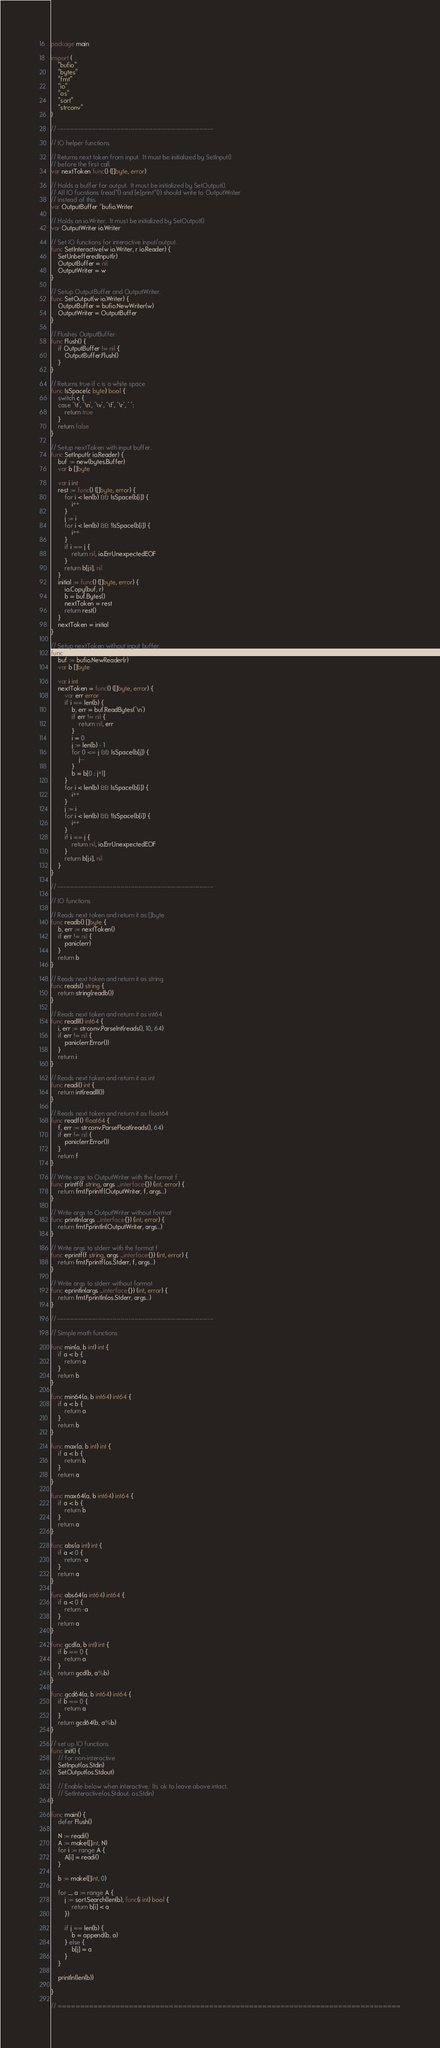<code> <loc_0><loc_0><loc_500><loc_500><_Go_>package main

import (
	"bufio"
	"bytes"
	"fmt"
	"io"
	"os"
	"sort"
	"strconv"
)

// -----------------------------------------------------------------------------

// IO helper functions

// Returns next token from input.  It must be initialized by SetInput()
// before the first call.
var nextToken func() ([]byte, error)

// Holds a buffer for output.  It must be initialized by SetOutput().
// All IO fucntions (read*() and [e]print*()) should write to OutputWriter
// instead of this.
var OutputBuffer *bufio.Writer

// Holds an io.Writer.  It must be initialized by SetOutput()
var OutputWriter io.Writer

// Set IO functions for interactive input/output.
func SetInteractive(w io.Writer, r io.Reader) {
	SetUnbefferedInput(r)
	OutputBuffer = nil
	OutputWriter = w
}

// Setup OutputBuffer and OutputWriter.
func SetOutput(w io.Writer) {
	OutputBuffer = bufio.NewWriter(w)
	OutputWriter = OutputBuffer
}

// Flushes OutputBuffer
func Flush() {
	if OutputBuffer != nil {
		OutputBuffer.Flush()
	}
}

// Returns true if c is a white space
func IsSpace(c byte) bool {
	switch c {
	case '\t', '\n', '\v', '\f', '\r', ' ':
		return true
	}
	return false
}

// Setup nextToken with input buffer.
func SetInput(r io.Reader) {
	buf := new(bytes.Buffer)
	var b []byte

	var i int
	rest := func() ([]byte, error) {
		for i < len(b) && IsSpace(b[i]) {
			i++
		}
		j := i
		for i < len(b) && !IsSpace(b[i]) {
			i++
		}
		if i == j {
			return nil, io.ErrUnexpectedEOF
		}
		return b[j:i], nil
	}
	initial := func() ([]byte, error) {
		io.Copy(buf, r)
		b = buf.Bytes()
		nextToken = rest
		return rest()
	}
	nextToken = initial
}

// Setup nextToken without input buffer.
func SetUnbefferedInput(r io.Reader) {
	buf := bufio.NewReader(r)
	var b []byte

	var i int
	nextToken = func() ([]byte, error) {
		var err error
		if i == len(b) {
			b, err = buf.ReadBytes('\n')
			if err != nil {
				return nil, err
			}
			i = 0
			j := len(b) - 1
			for 0 <= j && IsSpace(b[j]) {
				j--
			}
			b = b[0 : j+1]
		}
		for i < len(b) && IsSpace(b[i]) {
			i++
		}
		j := i
		for i < len(b) && !IsSpace(b[i]) {
			i++
		}
		if i == j {
			return nil, io.ErrUnexpectedEOF
		}
		return b[j:i], nil
	}
}

// -----------------------------------------------------------------------------

// IO functions

// Reads next token and return it as []byte
func readb() []byte {
	b, err := nextToken()
	if err != nil {
		panic(err)
	}
	return b
}

// Reads next token and return it as string
func reads() string {
	return string(readb())
}

// Reads next token and return it as int64
func readll() int64 {
	i, err := strconv.ParseInt(reads(), 10, 64)
	if err != nil {
		panic(err.Error())
	}
	return i
}

// Reads next token and return it as int
func readi() int {
	return int(readll())
}

// Reads next token and return it as float64
func readf() float64 {
	f, err := strconv.ParseFloat(reads(), 64)
	if err != nil {
		panic(err.Error())
	}
	return f
}

// Write args to OutputWriter with the format f
func printf(f string, args ...interface{}) (int, error) {
	return fmt.Fprintf(OutputWriter, f, args...)
}

// Write args to OutputWriter without format
func println(args ...interface{}) (int, error) {
	return fmt.Fprintln(OutputWriter, args...)
}

// Write args to stderr with the format f
func eprintf(f string, args ...interface{}) (int, error) {
	return fmt.Fprintf(os.Stderr, f, args...)
}

// Write args to stderr without format
func eprintln(args ...interface{}) (int, error) {
	return fmt.Fprintln(os.Stderr, args...)
}

// -----------------------------------------------------------------------------

// Simple math functions

func min(a, b int) int {
	if a < b {
		return a
	}
	return b
}

func min64(a, b int64) int64 {
	if a < b {
		return a
	}
	return b
}

func max(a, b int) int {
	if a < b {
		return b
	}
	return a
}

func max64(a, b int64) int64 {
	if a < b {
		return b
	}
	return a
}

func abs(a int) int {
	if a < 0 {
		return -a
	}
	return a
}

func abs64(a int64) int64 {
	if a < 0 {
		return -a
	}
	return a
}

func gcd(a, b int) int {
	if b == 0 {
		return a
	}
	return gcd(b, a%b)
}

func gcd64(a, b int64) int64 {
	if b == 0 {
		return a
	}
	return gcd64(b, a%b)
}

// set up IO functions
func init() {
	// for non-interactive
	SetInput(os.Stdin)
	SetOutput(os.Stdout)

	// Enable below when interactive.  Its ok to leave above intact.
	// SetInteractive(os.Stdout, os.Stdin)
}

func main() {
	defer Flush()

	N := readi()
	A := make([]int, N)
	for i := range A {
		A[i] = readi()
	}

	b := make([]int, 0)

	for _, a := range A {
		j := sort.Search(len(b), func(i int) bool {
			return b[i] < a
		})

		if j == len(b) {
			b = append(b, a)
		} else {
			b[j] = a
		}
	}

	println(len(b))

}

// =============================================================================
</code> 